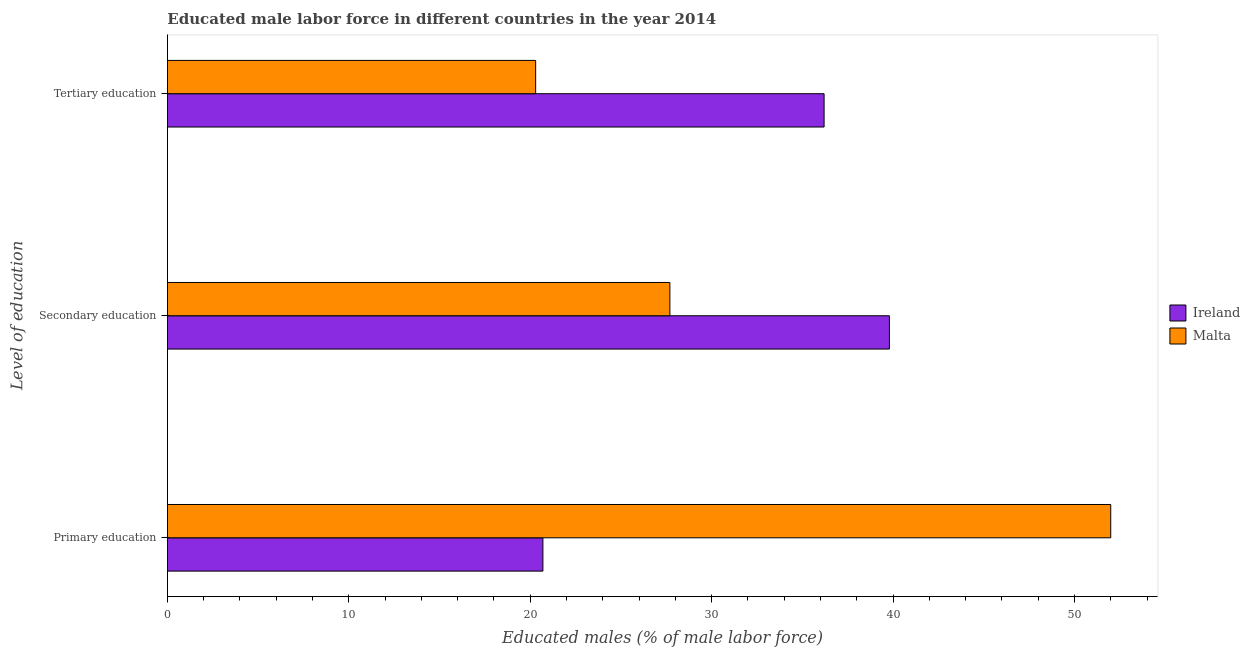How many different coloured bars are there?
Offer a terse response. 2. Are the number of bars per tick equal to the number of legend labels?
Make the answer very short. Yes. How many bars are there on the 1st tick from the bottom?
Keep it short and to the point. 2. What is the label of the 2nd group of bars from the top?
Offer a very short reply. Secondary education. What is the percentage of male labor force who received tertiary education in Malta?
Provide a short and direct response. 20.3. Across all countries, what is the minimum percentage of male labor force who received secondary education?
Offer a very short reply. 27.7. In which country was the percentage of male labor force who received primary education maximum?
Make the answer very short. Malta. In which country was the percentage of male labor force who received secondary education minimum?
Your answer should be compact. Malta. What is the total percentage of male labor force who received primary education in the graph?
Ensure brevity in your answer.  72.7. What is the difference between the percentage of male labor force who received primary education in Ireland and that in Malta?
Your answer should be compact. -31.3. What is the difference between the percentage of male labor force who received secondary education in Ireland and the percentage of male labor force who received primary education in Malta?
Your answer should be very brief. -12.2. What is the average percentage of male labor force who received secondary education per country?
Make the answer very short. 33.75. What is the difference between the percentage of male labor force who received secondary education and percentage of male labor force who received primary education in Ireland?
Provide a succinct answer. 19.1. In how many countries, is the percentage of male labor force who received primary education greater than 38 %?
Ensure brevity in your answer.  1. What is the ratio of the percentage of male labor force who received primary education in Ireland to that in Malta?
Give a very brief answer. 0.4. Is the percentage of male labor force who received tertiary education in Malta less than that in Ireland?
Make the answer very short. Yes. What is the difference between the highest and the second highest percentage of male labor force who received primary education?
Make the answer very short. 31.3. What is the difference between the highest and the lowest percentage of male labor force who received primary education?
Your answer should be very brief. 31.3. In how many countries, is the percentage of male labor force who received tertiary education greater than the average percentage of male labor force who received tertiary education taken over all countries?
Provide a short and direct response. 1. What does the 2nd bar from the top in Primary education represents?
Keep it short and to the point. Ireland. What does the 2nd bar from the bottom in Primary education represents?
Your answer should be very brief. Malta. Is it the case that in every country, the sum of the percentage of male labor force who received primary education and percentage of male labor force who received secondary education is greater than the percentage of male labor force who received tertiary education?
Offer a terse response. Yes. How many countries are there in the graph?
Your response must be concise. 2. What is the difference between two consecutive major ticks on the X-axis?
Offer a terse response. 10. Are the values on the major ticks of X-axis written in scientific E-notation?
Keep it short and to the point. No. Does the graph contain any zero values?
Your answer should be very brief. No. Does the graph contain grids?
Make the answer very short. No. How many legend labels are there?
Offer a very short reply. 2. How are the legend labels stacked?
Make the answer very short. Vertical. What is the title of the graph?
Keep it short and to the point. Educated male labor force in different countries in the year 2014. What is the label or title of the X-axis?
Offer a terse response. Educated males (% of male labor force). What is the label or title of the Y-axis?
Make the answer very short. Level of education. What is the Educated males (% of male labor force) in Ireland in Primary education?
Keep it short and to the point. 20.7. What is the Educated males (% of male labor force) of Ireland in Secondary education?
Provide a succinct answer. 39.8. What is the Educated males (% of male labor force) of Malta in Secondary education?
Your answer should be very brief. 27.7. What is the Educated males (% of male labor force) in Ireland in Tertiary education?
Your answer should be very brief. 36.2. What is the Educated males (% of male labor force) of Malta in Tertiary education?
Provide a succinct answer. 20.3. Across all Level of education, what is the maximum Educated males (% of male labor force) of Ireland?
Give a very brief answer. 39.8. Across all Level of education, what is the minimum Educated males (% of male labor force) in Ireland?
Your answer should be compact. 20.7. Across all Level of education, what is the minimum Educated males (% of male labor force) of Malta?
Your answer should be compact. 20.3. What is the total Educated males (% of male labor force) in Ireland in the graph?
Your answer should be very brief. 96.7. What is the total Educated males (% of male labor force) in Malta in the graph?
Provide a short and direct response. 100. What is the difference between the Educated males (% of male labor force) of Ireland in Primary education and that in Secondary education?
Keep it short and to the point. -19.1. What is the difference between the Educated males (% of male labor force) of Malta in Primary education and that in Secondary education?
Your answer should be very brief. 24.3. What is the difference between the Educated males (% of male labor force) of Ireland in Primary education and that in Tertiary education?
Give a very brief answer. -15.5. What is the difference between the Educated males (% of male labor force) of Malta in Primary education and that in Tertiary education?
Ensure brevity in your answer.  31.7. What is the difference between the Educated males (% of male labor force) in Ireland in Secondary education and the Educated males (% of male labor force) in Malta in Tertiary education?
Ensure brevity in your answer.  19.5. What is the average Educated males (% of male labor force) in Ireland per Level of education?
Your answer should be very brief. 32.23. What is the average Educated males (% of male labor force) in Malta per Level of education?
Make the answer very short. 33.33. What is the difference between the Educated males (% of male labor force) of Ireland and Educated males (% of male labor force) of Malta in Primary education?
Provide a succinct answer. -31.3. What is the difference between the Educated males (% of male labor force) in Ireland and Educated males (% of male labor force) in Malta in Secondary education?
Offer a very short reply. 12.1. What is the ratio of the Educated males (% of male labor force) in Ireland in Primary education to that in Secondary education?
Offer a terse response. 0.52. What is the ratio of the Educated males (% of male labor force) of Malta in Primary education to that in Secondary education?
Offer a very short reply. 1.88. What is the ratio of the Educated males (% of male labor force) in Ireland in Primary education to that in Tertiary education?
Give a very brief answer. 0.57. What is the ratio of the Educated males (% of male labor force) in Malta in Primary education to that in Tertiary education?
Your response must be concise. 2.56. What is the ratio of the Educated males (% of male labor force) of Ireland in Secondary education to that in Tertiary education?
Ensure brevity in your answer.  1.1. What is the ratio of the Educated males (% of male labor force) of Malta in Secondary education to that in Tertiary education?
Offer a very short reply. 1.36. What is the difference between the highest and the second highest Educated males (% of male labor force) of Malta?
Provide a succinct answer. 24.3. What is the difference between the highest and the lowest Educated males (% of male labor force) of Malta?
Your answer should be compact. 31.7. 